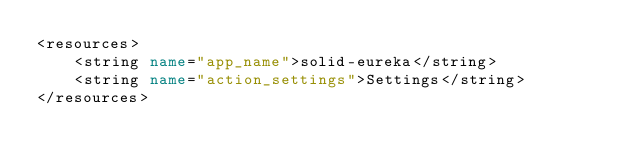Convert code to text. <code><loc_0><loc_0><loc_500><loc_500><_XML_><resources>
    <string name="app_name">solid-eureka</string>
    <string name="action_settings">Settings</string>
</resources>
</code> 